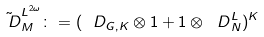<formula> <loc_0><loc_0><loc_500><loc_500>\tilde { \ D } _ { M } ^ { { L ^ { 2 \omega } } } \colon = ( { \ D } _ { G , K } \otimes 1 + 1 \otimes { \ D } _ { N } ^ { L } ) ^ { K }</formula> 